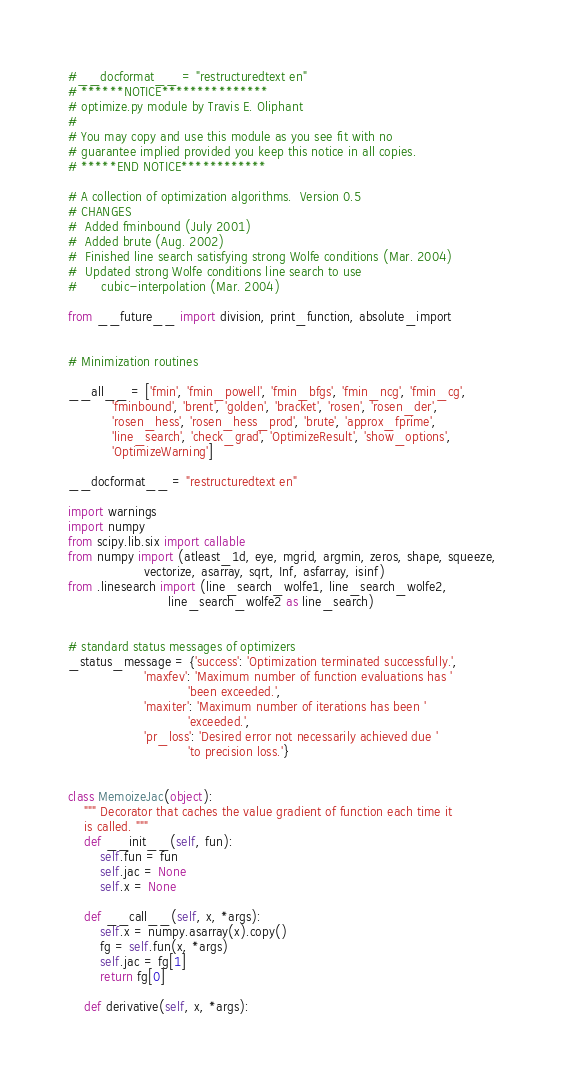Convert code to text. <code><loc_0><loc_0><loc_500><loc_500><_Python_>#__docformat__ = "restructuredtext en"
# ******NOTICE***************
# optimize.py module by Travis E. Oliphant
#
# You may copy and use this module as you see fit with no
# guarantee implied provided you keep this notice in all copies.
# *****END NOTICE************

# A collection of optimization algorithms.  Version 0.5
# CHANGES
#  Added fminbound (July 2001)
#  Added brute (Aug. 2002)
#  Finished line search satisfying strong Wolfe conditions (Mar. 2004)
#  Updated strong Wolfe conditions line search to use
#      cubic-interpolation (Mar. 2004)

from __future__ import division, print_function, absolute_import


# Minimization routines

__all__ = ['fmin', 'fmin_powell', 'fmin_bfgs', 'fmin_ncg', 'fmin_cg',
           'fminbound', 'brent', 'golden', 'bracket', 'rosen', 'rosen_der',
           'rosen_hess', 'rosen_hess_prod', 'brute', 'approx_fprime',
           'line_search', 'check_grad', 'OptimizeResult', 'show_options',
           'OptimizeWarning']

__docformat__ = "restructuredtext en"

import warnings
import numpy
from scipy.lib.six import callable
from numpy import (atleast_1d, eye, mgrid, argmin, zeros, shape, squeeze,
                   vectorize, asarray, sqrt, Inf, asfarray, isinf)
from .linesearch import (line_search_wolfe1, line_search_wolfe2,
                         line_search_wolfe2 as line_search)


# standard status messages of optimizers
_status_message = {'success': 'Optimization terminated successfully.',
                   'maxfev': 'Maximum number of function evaluations has '
                              'been exceeded.',
                   'maxiter': 'Maximum number of iterations has been '
                              'exceeded.',
                   'pr_loss': 'Desired error not necessarily achieved due '
                              'to precision loss.'}


class MemoizeJac(object):
    """ Decorator that caches the value gradient of function each time it
    is called. """
    def __init__(self, fun):
        self.fun = fun
        self.jac = None
        self.x = None

    def __call__(self, x, *args):
        self.x = numpy.asarray(x).copy()
        fg = self.fun(x, *args)
        self.jac = fg[1]
        return fg[0]

    def derivative(self, x, *args):</code> 